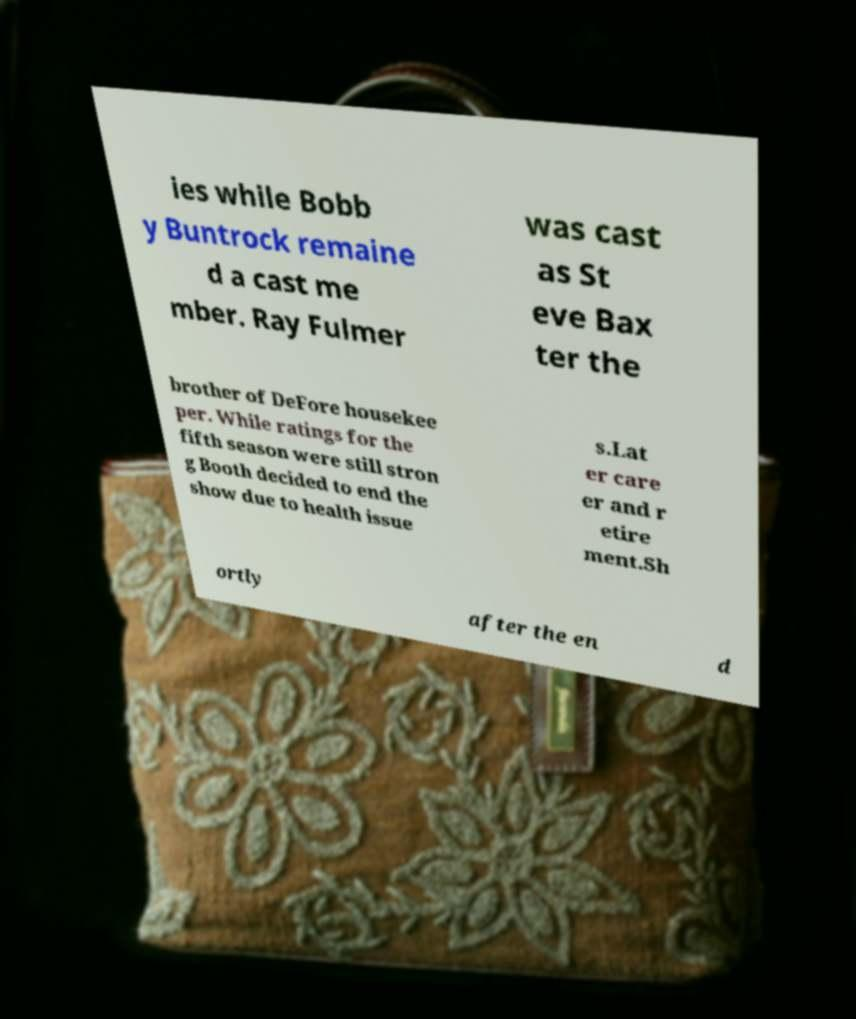Could you extract and type out the text from this image? ies while Bobb y Buntrock remaine d a cast me mber. Ray Fulmer was cast as St eve Bax ter the brother of DeFore housekee per. While ratings for the fifth season were still stron g Booth decided to end the show due to health issue s.Lat er care er and r etire ment.Sh ortly after the en d 